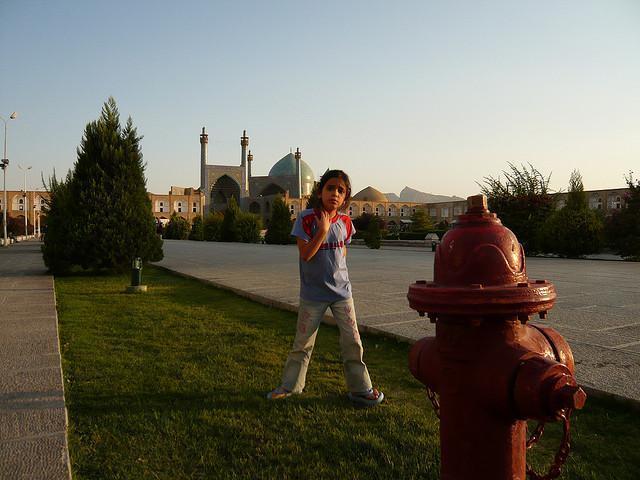How many children are here?
Give a very brief answer. 1. How many people are there?
Give a very brief answer. 1. How many giraffes are in the picture?
Give a very brief answer. 0. 